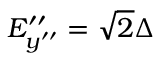<formula> <loc_0><loc_0><loc_500><loc_500>E _ { y ^ { \prime \prime } } ^ { \prime \prime } = \sqrt { 2 } \Delta</formula> 